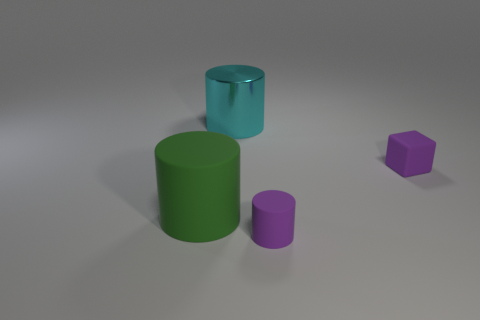Is there a large thing that has the same material as the purple block?
Give a very brief answer. Yes. There is a thing that is the same color as the tiny matte cylinder; what size is it?
Offer a terse response. Small. What number of cubes are small purple metal objects or green objects?
Your response must be concise. 0. Are there more green cylinders that are in front of the large shiny thing than purple cylinders that are behind the cube?
Provide a succinct answer. Yes. What number of small cubes are the same color as the tiny matte cylinder?
Ensure brevity in your answer.  1. What size is the cube that is made of the same material as the green object?
Your answer should be very brief. Small. What number of objects are either things in front of the green cylinder or small yellow rubber balls?
Make the answer very short. 1. There is a rubber cylinder that is right of the cyan thing; does it have the same color as the tiny rubber cube?
Ensure brevity in your answer.  Yes. What is the size of the cyan metal thing that is the same shape as the large green object?
Your answer should be very brief. Large. There is a tiny matte thing to the right of the matte cylinder on the right side of the large cylinder that is left of the large metallic cylinder; what is its color?
Offer a terse response. Purple. 